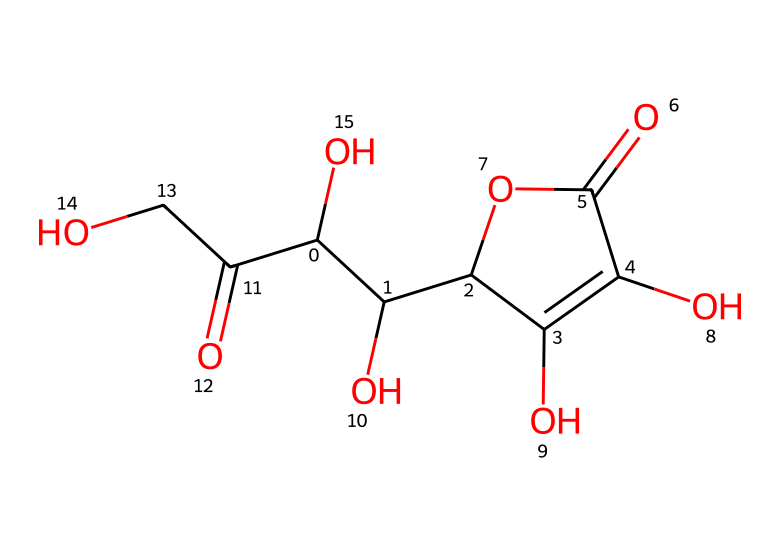How many carbon atoms are present in ascorbic acid? By analyzing the SMILES representation, we can identify the number of carbon atoms in the structure. Counting the letter 'C' in the SMILES string shows that there are six carbon atoms.
Answer: six What functional groups are present in the structure of ascorbic acid? Looking at the SMILES representation, we can identify the functional groups by recognizing specific arrangements. The structure contains hydroxyl groups (-OH) and a carboxylic acid group (-COOH), which are characteristic of ascorbic acid.
Answer: hydroxyl and carboxylic acid What is the molecular weight of ascorbic acid? To calculate the molecular weight, we need to consider the total number of each type of atom from the chemical structure and multiply by their atomic weights. After calculating it based on six carbons, eight hydrogens, and six oxygens, the molecular weight totals approximately 176.12 g/mol.
Answer: 176.12 g/mol Does ascorbic acid act as an acid? The presence of the carboxylic acid group (-COOH) in the structure indicates that ascorbic acid can donate a hydrogen ion (H+), thus acting as an acid.
Answer: yes What type of acid is ascorbic acid? Given its nature and functionality, ascorbic acid is classified specifically as a weak organic acid due to its structure containing hydroxyl groups and a carboxylic acid.
Answer: weak organic acid How many oxygen atoms are found in ascorbic acid? Based on the SMILES representation, counting each letter 'O' reveals that there are four oxygen atoms in the structure of ascorbic acid.
Answer: four 